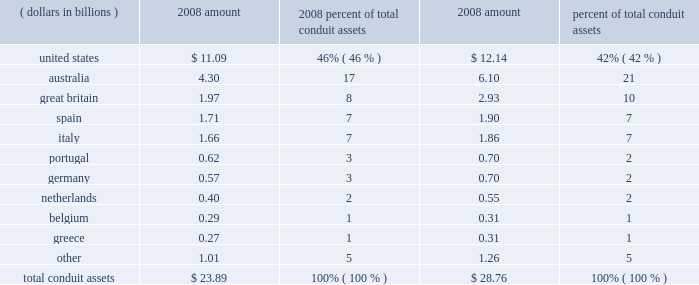Conduit assets by asset origin .
The conduits meet the definition of a vie , as defined by fin 46 ( r ) .
We have determined that we are not the primary beneficiary of the conduits , as defined by fin 46 ( r ) , and do not record them in our consolidated financial statements .
We hold no direct or indirect ownership interest in the conduits , but we provide subordinated financial support to them through contractual arrangements .
Standby letters of credit absorb certain actual credit losses from the conduit assets ; our commitment under these letters of credit totaled $ 1.00 billion and $ 1.04 billion at december 31 , 2008 and 2007 , respectively .
Liquidity asset purchase agreements provide liquidity to the conduits in the event they cannot place commercial paper in the ordinary course of their business ; these facilities , which require us to purchase assets from the conduits at par , would provide the needed liquidity to repay maturing commercial paper if there was a disruption in the asset-backed commercial paper market .
The aggregate commitment under the liquidity asset purchase agreements was approximately $ 23.59 billion and $ 28.37 billion at december 31 , 2008 and 2007 , respectively .
We did not accrue for any losses associated with either our commitment under the standby letters of credit or the liquidity asset purchase agreements in our consolidated statement of condition at december 31 , 2008 or 2007 .
During the first quarter of 2008 , pursuant to the contractual terms of our liquidity asset purchase agreements with the conduits , we were required to purchase $ 850 million of conduit assets .
The purchase was the result of various factors , including the continued illiquidity in the commercial paper markets .
The securities were purchased at prices determined in accordance with existing contractual terms in the liquidity asset purchase agreements , and which exceeded their fair value .
Accordingly , during the first quarter of 2008 , the securities were written down to their fair value through a $ 12 million reduction of processing fees and other revenue in our consolidated statement of income , and are carried at fair value in securities available for sale in our consolidated statement of condition .
None of our liquidity asset purchase agreements with the conduits were drawn upon during the remainder of 2008 , and no draw-downs on the standby letters of credit occurred during 2008 .
The conduits generally sell commercial paper to independent third-party investors .
However , we sometimes purchase commercial paper from the conduits .
As of december 31 , 2008 , we held an aggregate of approximately $ 230 million of commercial paper issued by the conduits , and $ 2 million at december 31 , 2007 .
In addition , approximately $ 5.70 billion of u.s .
Conduit-issued commercial paper had been sold to the cpff .
The cpff is scheduled to expire on october 31 , 2009 .
The weighted-average maturity of the conduits 2019 commercial paper in the aggregate was approximately 25 days as of december 31 , 2008 , compared to approximately 20 days as of december 31 , 2007 .
Each of the conduits has issued first-loss notes to independent third parties , which third parties absorb first- dollar losses related to credit risk .
Aggregate first-loss notes outstanding at december 31 , 2008 for the four conduits totaled $ 67 million , compared to $ 32 million at december 31 , 2007 .
Actual credit losses of the conduits .
What is the percentage change in conduit assets in unites states from 2007 to 2008? 
Computations: ((11.09 - 12.14) / 12.14)
Answer: -0.08649. 